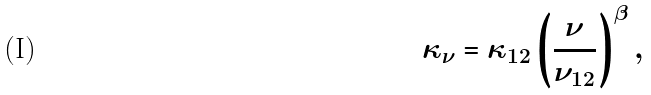Convert formula to latex. <formula><loc_0><loc_0><loc_500><loc_500>\kappa _ { \nu } = \kappa _ { 1 2 } \left ( \frac { \nu } { \nu _ { 1 2 } } \right ) ^ { \beta } ,</formula> 